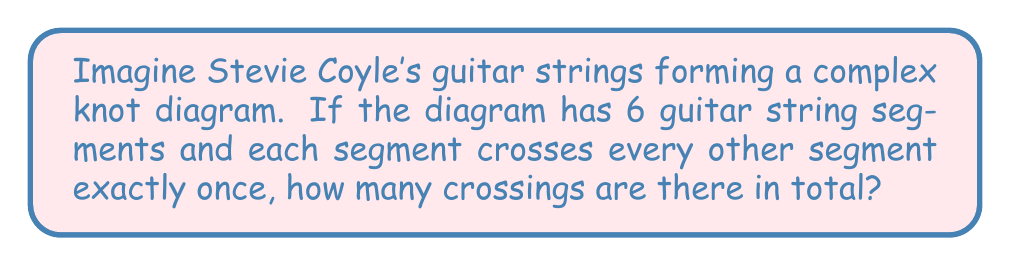What is the answer to this math problem? Let's approach this step-by-step:

1) First, we need to understand what the question is asking. We have 6 guitar string segments, and each segment crosses every other segment once.

2) In knot theory, this type of diagram is known as a complete graph, where every vertex (in this case, string segment) is connected to every other vertex exactly once.

3) To calculate the number of crossings, we need to determine how many pairs of segments there are. This is because each crossing involves two segments.

4) The number of pairs can be calculated using the combination formula:

   $$\binom{n}{2} = \frac{n!}{2!(n-2)!}$$

   where $n$ is the number of segments.

5) In this case, $n = 6$. Let's substitute this into our formula:

   $$\binom{6}{2} = \frac{6!}{2!(6-2)!} = \frac{6!}{2!4!}$$

6) Let's calculate this:
   
   $$\frac{6 * 5 * 4!}{2 * 1 * 4!} = \frac{30}{2} = 15$$

Therefore, there are 15 crossings in total.
Answer: 15 